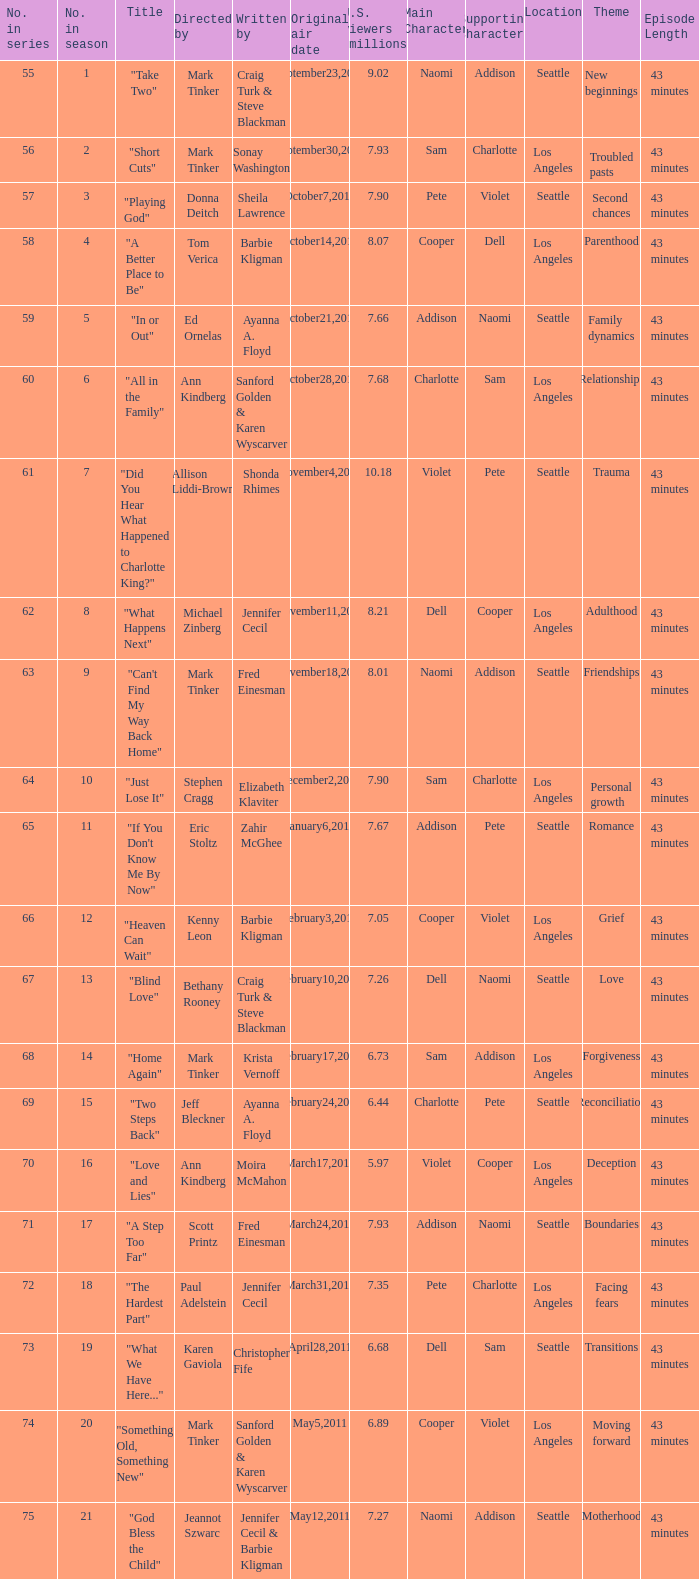What number episode in the season was directed by Paul Adelstein?  18.0. 